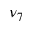<formula> <loc_0><loc_0><loc_500><loc_500>\nu _ { 7 }</formula> 